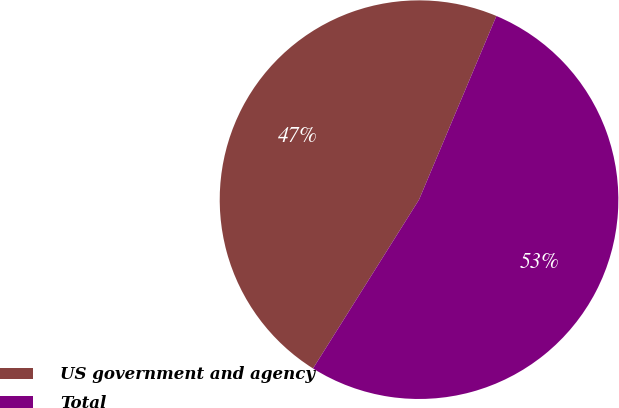Convert chart. <chart><loc_0><loc_0><loc_500><loc_500><pie_chart><fcel>US government and agency<fcel>Total<nl><fcel>47.42%<fcel>52.58%<nl></chart> 